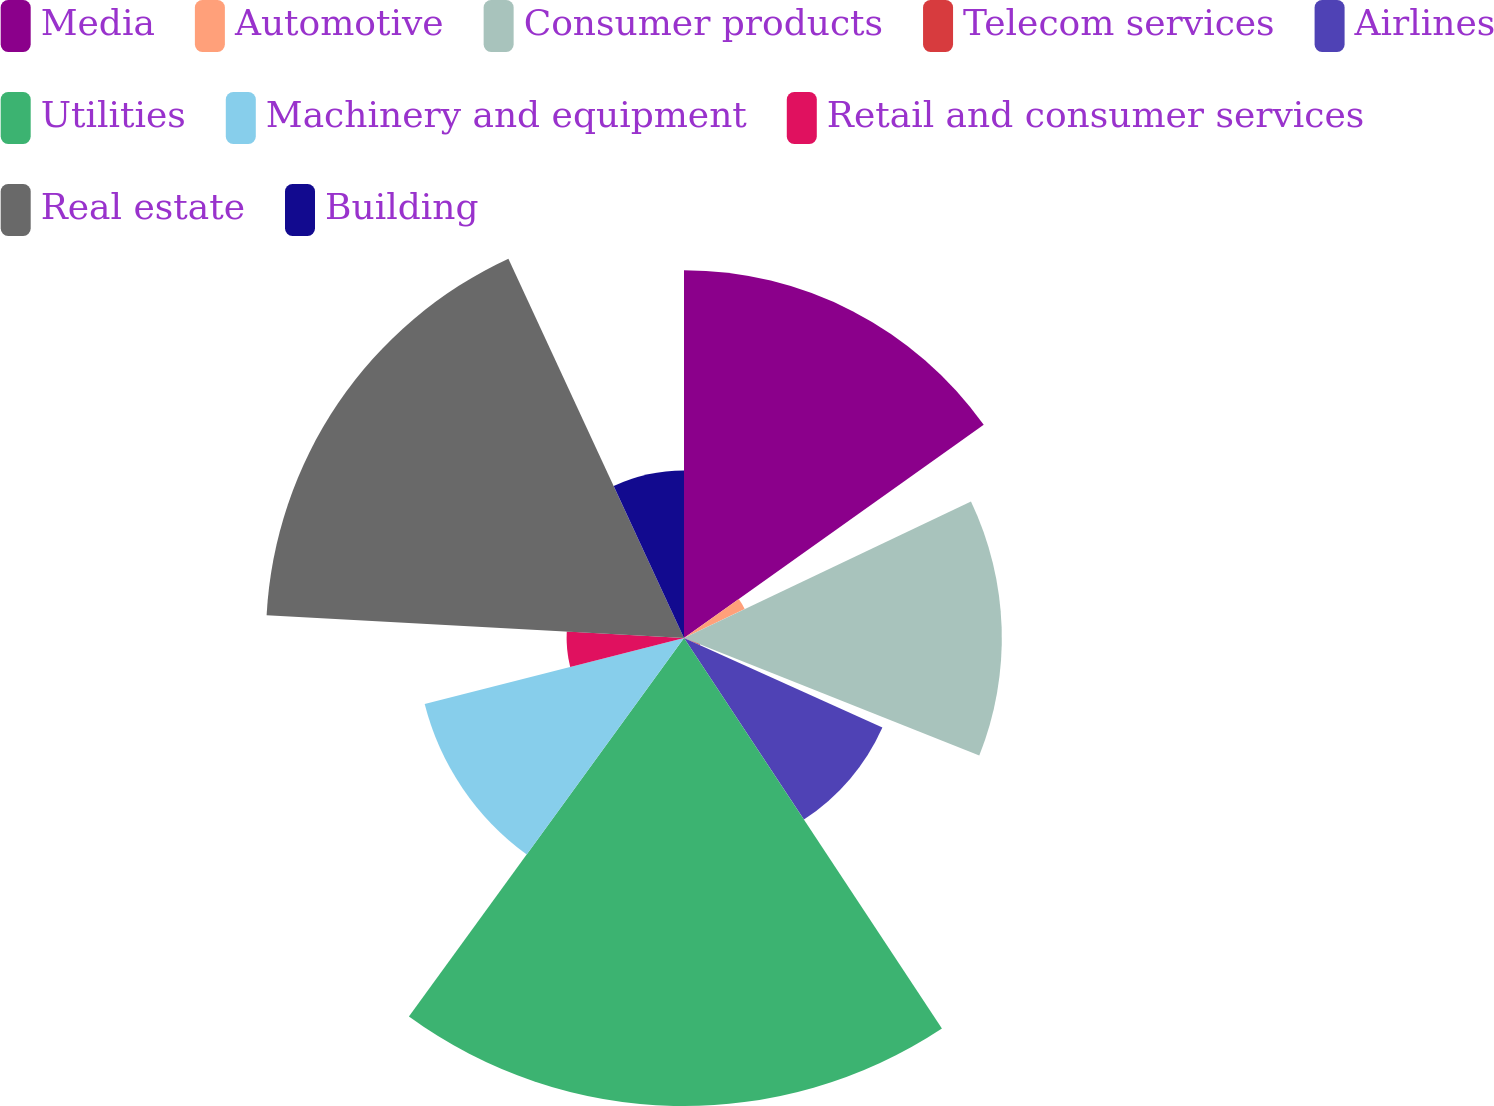Convert chart to OTSL. <chart><loc_0><loc_0><loc_500><loc_500><pie_chart><fcel>Media<fcel>Automotive<fcel>Consumer products<fcel>Telecom services<fcel>Airlines<fcel>Utilities<fcel>Machinery and equipment<fcel>Retail and consumer services<fcel>Real estate<fcel>Building<nl><fcel>15.16%<fcel>2.77%<fcel>13.1%<fcel>0.71%<fcel>8.97%<fcel>19.29%<fcel>11.03%<fcel>4.84%<fcel>17.23%<fcel>6.9%<nl></chart> 